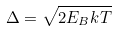Convert formula to latex. <formula><loc_0><loc_0><loc_500><loc_500>\Delta = \sqrt { 2 E _ { B } k T }</formula> 